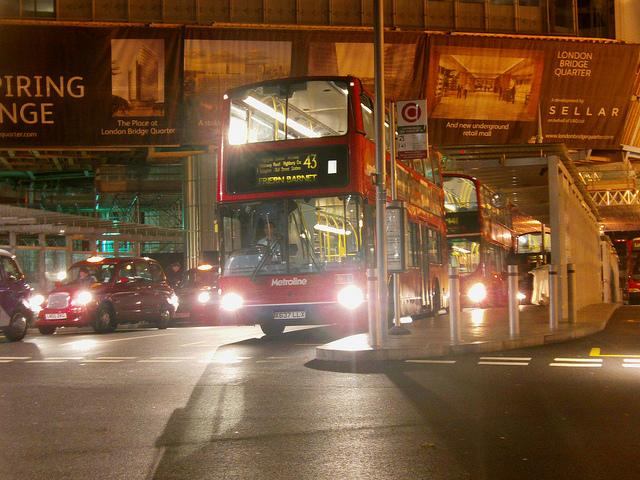What country is it?

Choices:
A) spain
B) britain
C) france
D) italy britain 